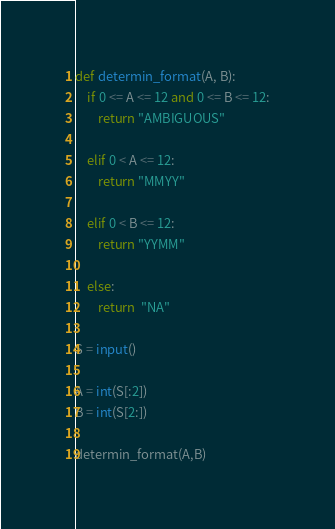<code> <loc_0><loc_0><loc_500><loc_500><_Python_>def determin_format(A, B):
    if 0 <= A <= 12 and 0 <= B <= 12:
        return "AMBIGUOUS"
    
    elif 0 < A <= 12:
        return "MMYY"
    
    elif 0 < B <= 12:
        return "YYMM"
    
    else: 
        return  "NA"

S = input()

A = int(S[:2])
B = int(S[2:])

determin_format(A,B)</code> 